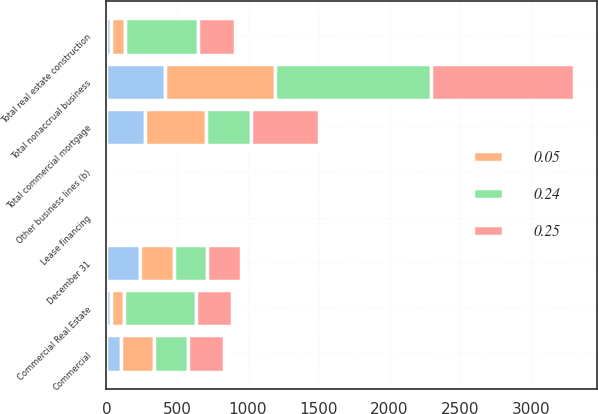Convert chart to OTSL. <chart><loc_0><loc_0><loc_500><loc_500><stacked_bar_chart><ecel><fcel>December 31<fcel>Commercial<fcel>Commercial Real Estate<fcel>Other business lines (b)<fcel>Total real estate construction<fcel>Total commercial mortgage<fcel>Lease financing<fcel>Total nonaccrual business<nl><fcel>nan<fcel>237.5<fcel>103<fcel>30<fcel>3<fcel>33<fcel>275<fcel>3<fcel>414<nl><fcel>0.05<fcel>237.5<fcel>237<fcel>93<fcel>8<fcel>101<fcel>427<fcel>5<fcel>778<nl><fcel>0.25<fcel>237.5<fcel>252<fcel>259<fcel>4<fcel>263<fcel>483<fcel>7<fcel>1007<nl><fcel>0.24<fcel>237.5<fcel>238<fcel>507<fcel>4<fcel>511<fcel>319<fcel>13<fcel>1103<nl></chart> 